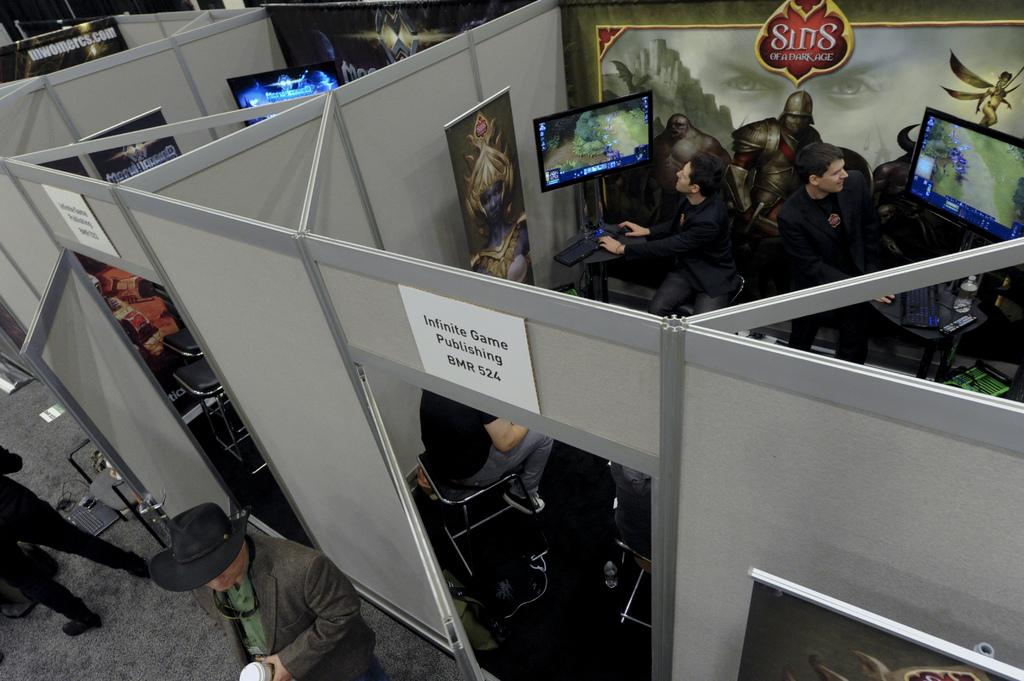<image>
Share a concise interpretation of the image provided. An Infinite Game Publishing cubicle with people inside on computers. 